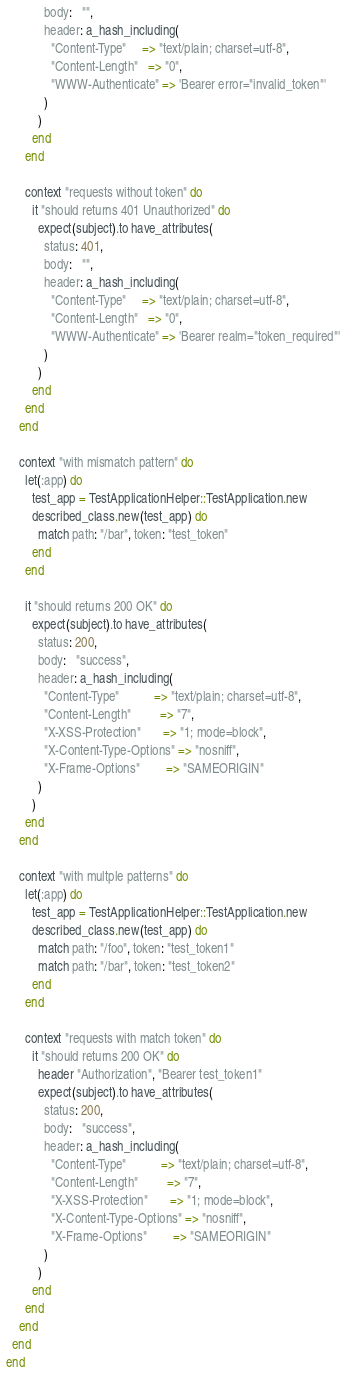Convert code to text. <code><loc_0><loc_0><loc_500><loc_500><_Ruby_>            body:   "",
            header: a_hash_including(
              "Content-Type"     => "text/plain; charset=utf-8",
              "Content-Length"   => "0",
              "WWW-Authenticate" => 'Bearer error="invalid_token"'
            )
          )
        end
      end

      context "requests without token" do
        it "should returns 401 Unauthorized" do
          expect(subject).to have_attributes(
            status: 401,
            body:   "",
            header: a_hash_including(
              "Content-Type"     => "text/plain; charset=utf-8",
              "Content-Length"   => "0",
              "WWW-Authenticate" => 'Bearer realm="token_required"'
            )
          )
        end
      end
    end

    context "with mismatch pattern" do
      let(:app) do
        test_app = TestApplicationHelper::TestApplication.new
        described_class.new(test_app) do
          match path: "/bar", token: "test_token"
        end
      end

      it "should returns 200 OK" do
        expect(subject).to have_attributes(
          status: 200,
          body:   "success",
          header: a_hash_including(
            "Content-Type"           => "text/plain; charset=utf-8",
            "Content-Length"         => "7",
            "X-XSS-Protection"       => "1; mode=block",
            "X-Content-Type-Options" => "nosniff",
            "X-Frame-Options"        => "SAMEORIGIN"
          )
        )
      end
    end

    context "with multple patterns" do
      let(:app) do
        test_app = TestApplicationHelper::TestApplication.new
        described_class.new(test_app) do
          match path: "/foo", token: "test_token1"
          match path: "/bar", token: "test_token2"
        end
      end

      context "requests with match token" do
        it "should returns 200 OK" do
          header "Authorization", "Bearer test_token1"
          expect(subject).to have_attributes(
            status: 200,
            body:   "success",
            header: a_hash_including(
              "Content-Type"           => "text/plain; charset=utf-8",
              "Content-Length"         => "7",
              "X-XSS-Protection"       => "1; mode=block",
              "X-Content-Type-Options" => "nosniff",
              "X-Frame-Options"        => "SAMEORIGIN"
            )
          )
        end
      end
    end
  end
end
</code> 